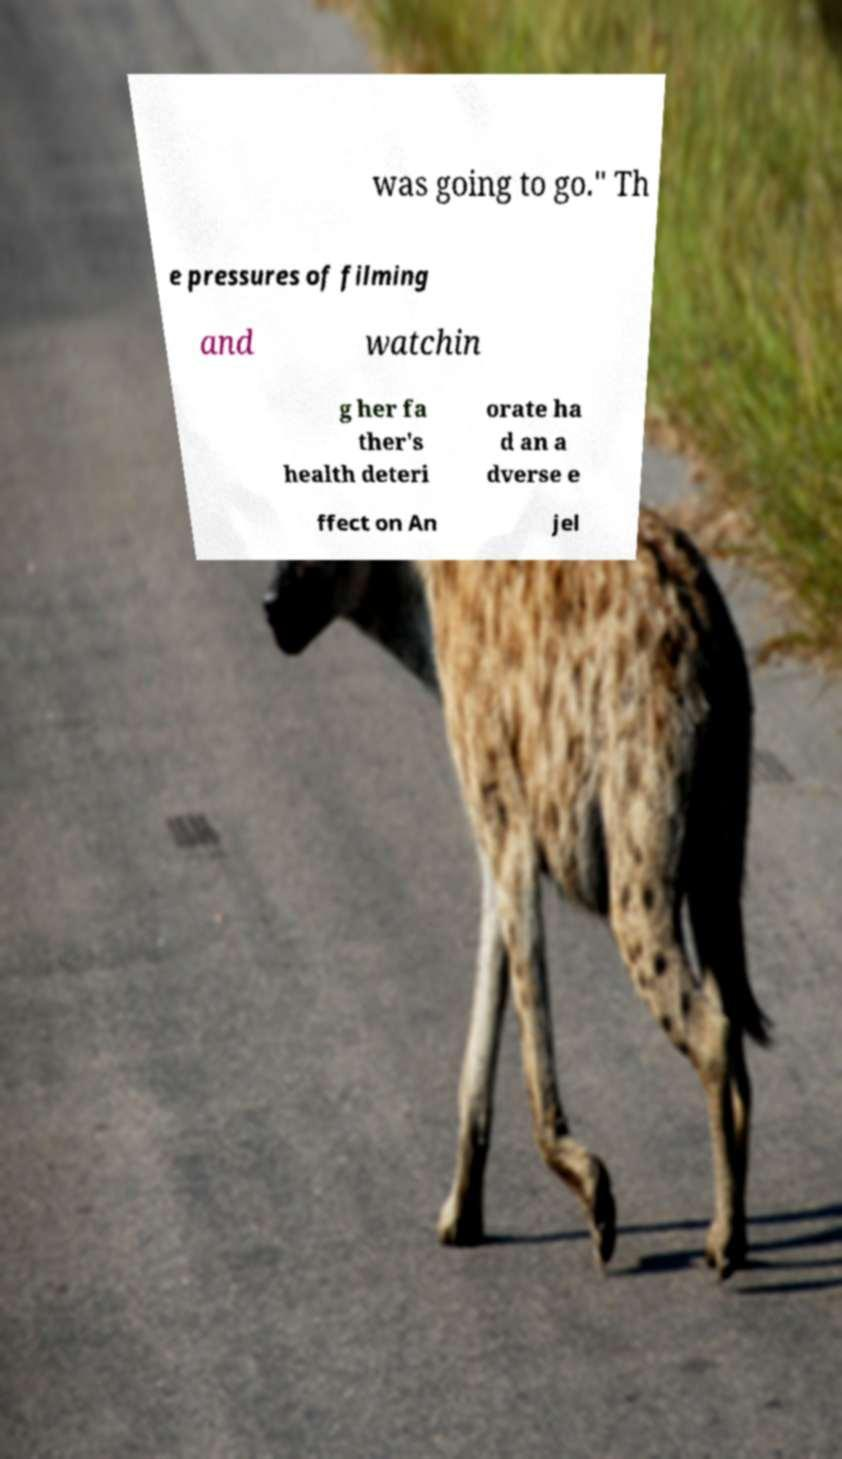Please read and relay the text visible in this image. What does it say? was going to go." Th e pressures of filming and watchin g her fa ther's health deteri orate ha d an a dverse e ffect on An jel 